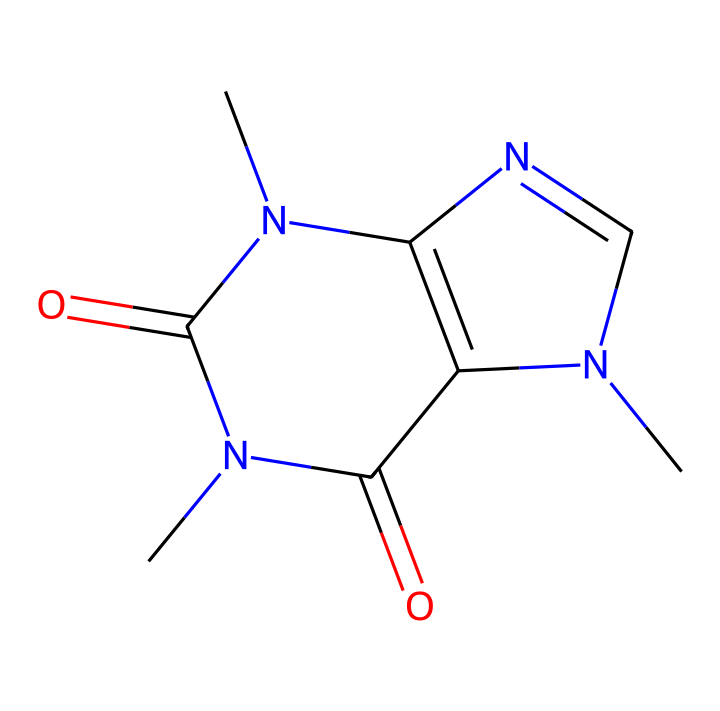What is the molecular formula of caffeine? To determine the molecular formula, we count the number of each type of atom in the chemical structure. From the SMILES representation, we identify the following: 8 Carbon (C), 10 Hydrogen (H), 4 Nitrogen (N), and 2 Oxygen (O) atoms. Therefore, the molecular formula is C8H10N4O2.
Answer: C8H10N4O2 How many nitrogen atoms are present in the structure? By examining the SMILES, we can see the nitrogen atoms (N) within the structure. Counting these nitrogen atoms reveals there are 4 nitrogen atoms.
Answer: 4 What functional groups are present in caffeine? Noting the components of the structure, we see the presence of amine (N) and carbonyl (C=O) groups. The amine groups are indicated by the nitrogen atoms bonded to carbon, and the carbonyl groups are indicated by the C=O connections in the structure.
Answer: amine, carbonyl How many rings are present in the caffeine structure? By analyzing the structure, we note that there are two interconnected rings. Counting the cyclic portions of the skeletal formula confirms that there are indeed two rings present.
Answer: 2 What is the primary role of caffeine in the human body? Caffeine primarily acts as a stimulant in the human body, promoting wakefulness and alertness by blocking the effects of adenosine, a neurotransmitter that promotes sleep. This function is a direct outcome of its chemical structure which allows it to interact with specific receptors in the brain.
Answer: stimulant Is caffeine considered an organometallic compound? Caffeine does not contain metal atoms bonded to carbon atoms in a typical organometallic fashion. Rather, it is classified as a methylxanthine derivative with no metal ions involved, thus it does not fit the definition of organometallic compounds.
Answer: no 